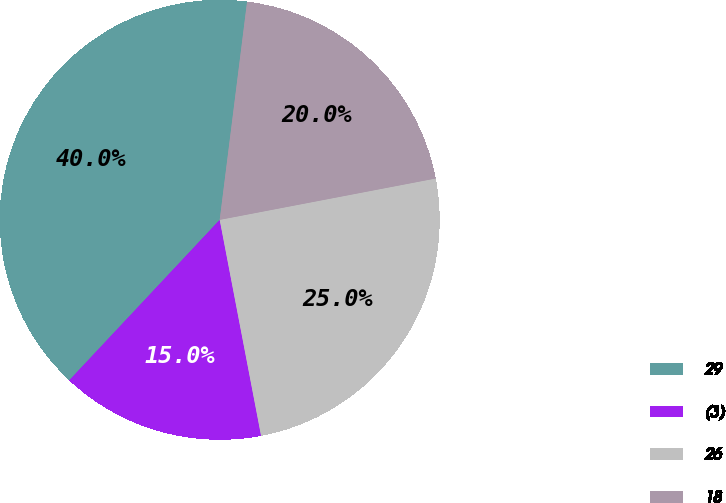Convert chart to OTSL. <chart><loc_0><loc_0><loc_500><loc_500><pie_chart><fcel>29<fcel>(3)<fcel>26<fcel>18<nl><fcel>40.0%<fcel>15.0%<fcel>25.0%<fcel>20.0%<nl></chart> 